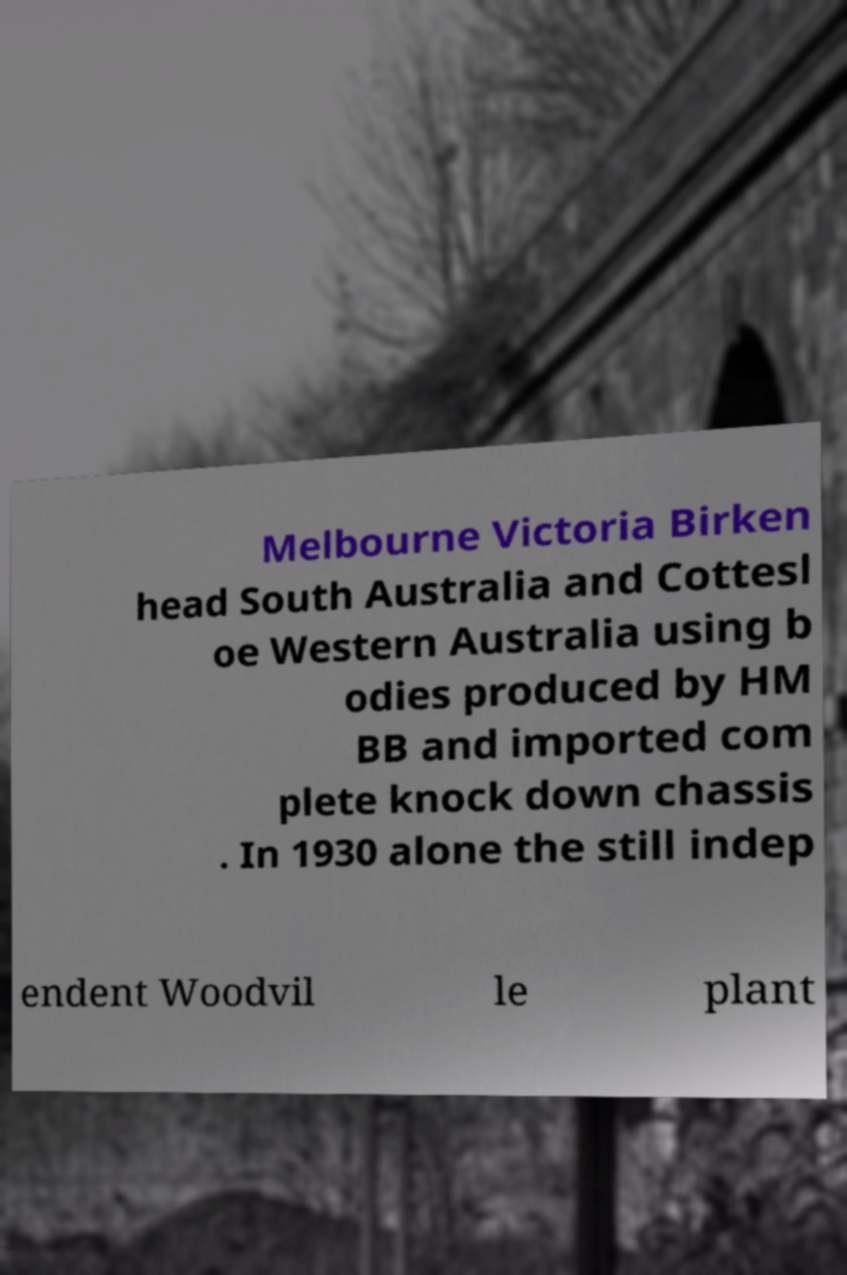For documentation purposes, I need the text within this image transcribed. Could you provide that? Melbourne Victoria Birken head South Australia and Cottesl oe Western Australia using b odies produced by HM BB and imported com plete knock down chassis . In 1930 alone the still indep endent Woodvil le plant 